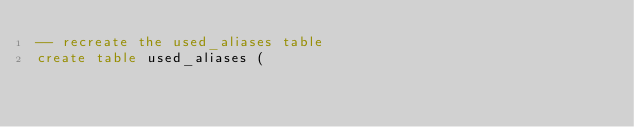Convert code to text. <code><loc_0><loc_0><loc_500><loc_500><_SQL_>-- recreate the used_aliases table
create table used_aliases (</code> 